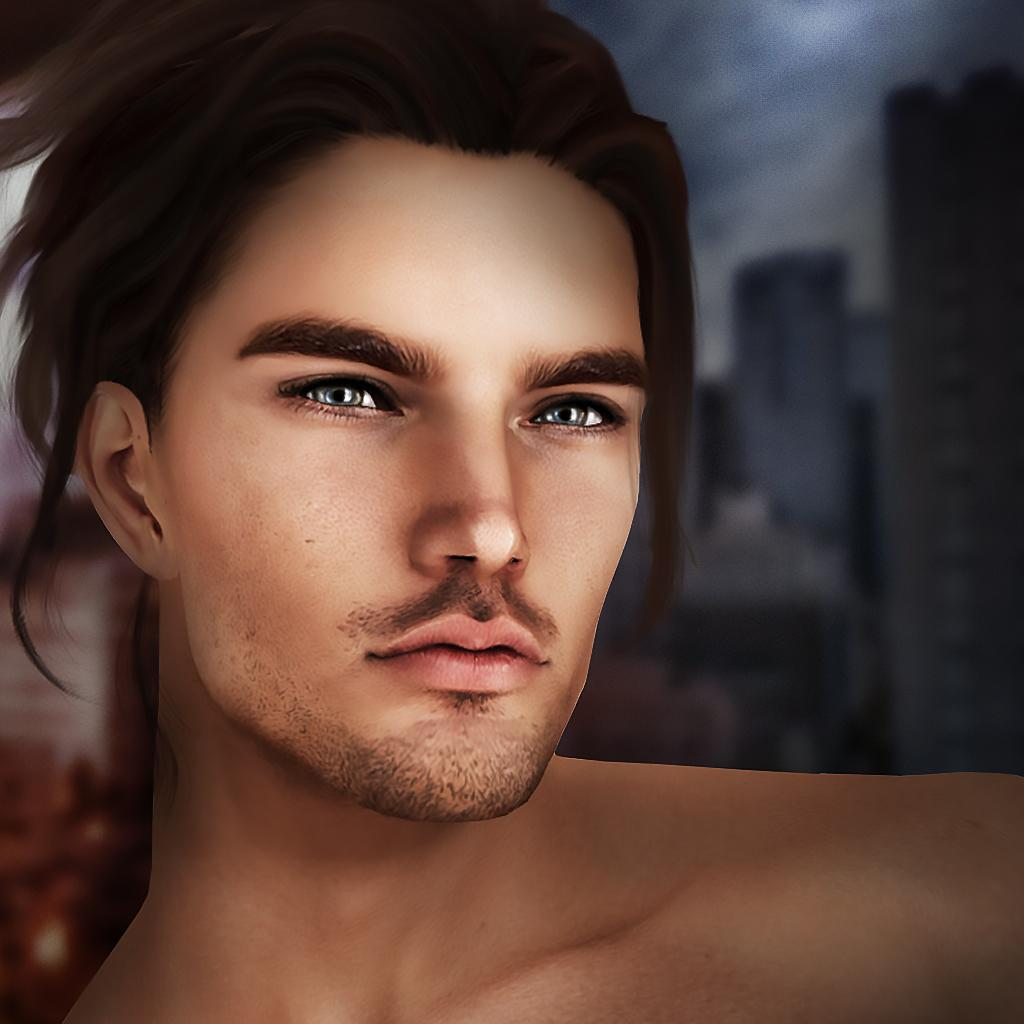What is the main subject in the foreground of the image? There is a person in the foreground of the image. What can be seen in the background of the image? There are buildings in the background of the image. Where is the kettle located in the image? There is no kettle present in the image. Is the person in the image standing in quicksand? There is no indication of quicksand in the image, and the person appears to be standing on a solid surface. 